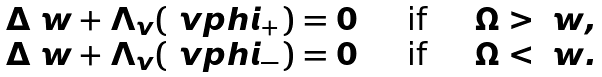Convert formula to latex. <formula><loc_0><loc_0><loc_500><loc_500>\begin{array} { r c l } \Delta \ w + \Lambda _ { v } ( \ v p h i _ { + } ) = 0 & \quad \text {if} \quad & \Omega > \ w , \\ \Delta \ w + \Lambda _ { v } ( \ v p h i _ { - } ) = 0 & \quad \text {if} \quad & \Omega < \ w . \end{array}</formula> 